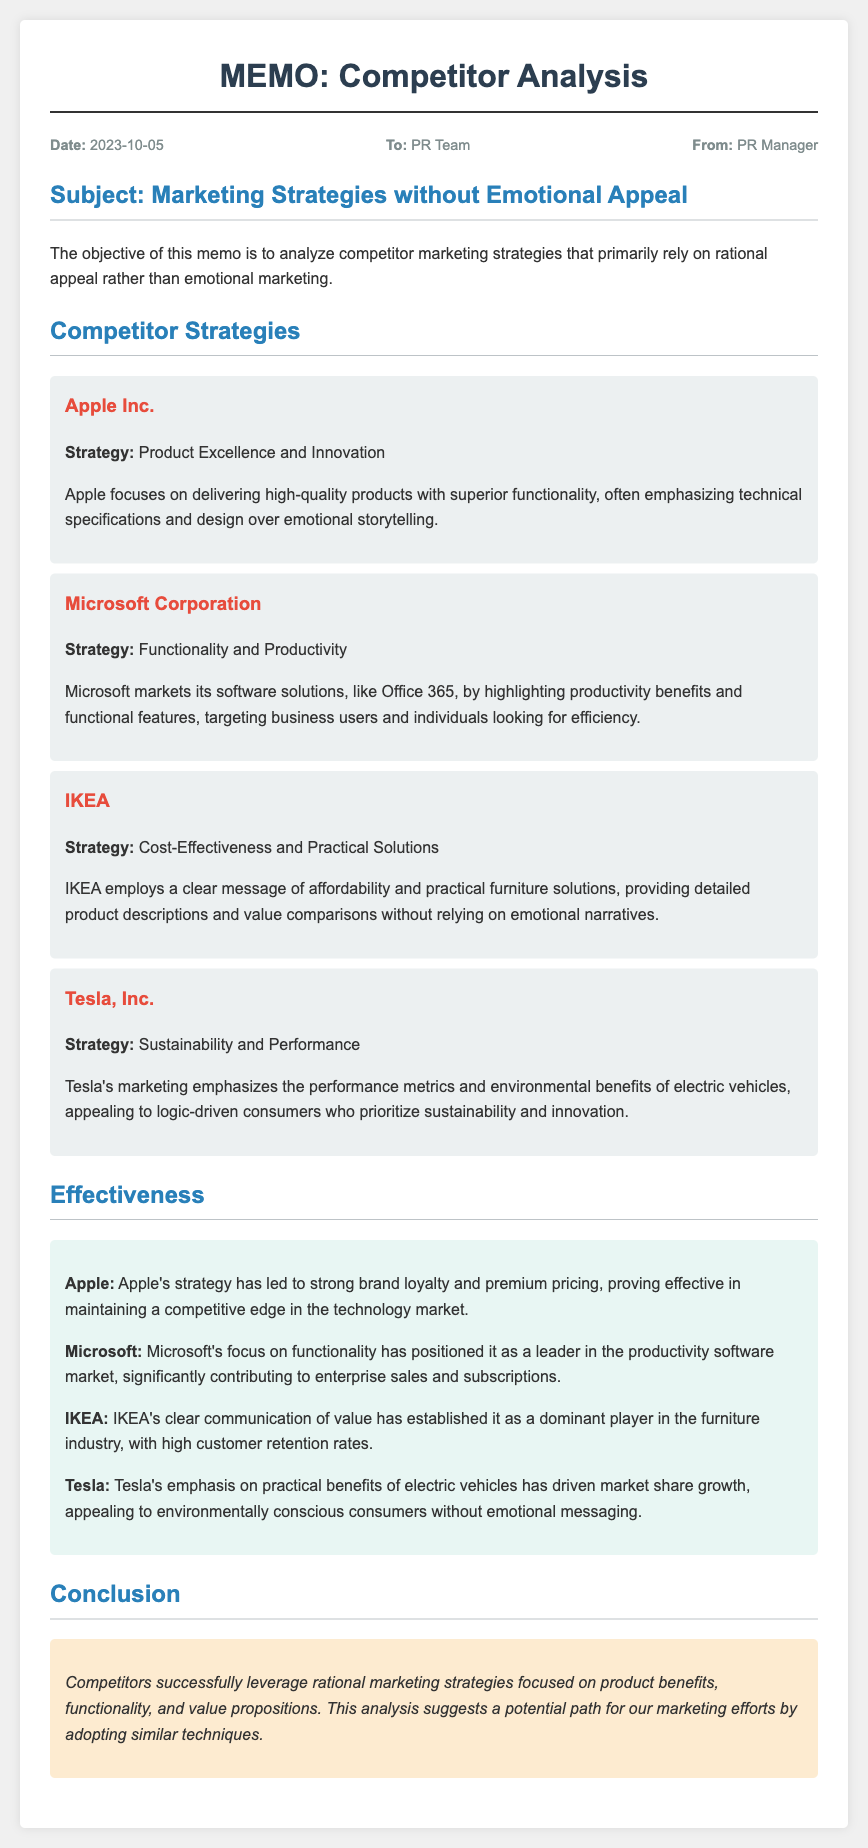What is the date of the memo? The date of the memo is explicitly stated in the meta section, which is October 5, 2023.
Answer: 2023-10-05 Who is the sender of the memo? The memo indicates the sender in the meta section, listed as the PR Manager.
Answer: PR Manager What strategy does Apple focus on? The document specifies that Apple’s strategy focuses on product excellence and innovation as a key approach.
Answer: Product Excellence and Innovation Which competitor emphasizes sustainability? The memo describes Tesla's strategy as emphasizing sustainability, highlighting its approach to marketing.
Answer: Tesla, Inc What is IKEA's marketing focus? IKEA's marketing strategy is clearly stated as being centered around cost-effectiveness and practical solutions.
Answer: Cost-Effectiveness and Practical Solutions How has Microsoft's strategy affected its market position? The effectiveness section indicates that Microsoft’s focus on functionality has significantly contributed to its enterprise sales and subscriptions.
Answer: Leader in the productivity software market What is the main conclusion drawn in the memo? The conclusion outlines that competitors effectively use rational marketing strategies focused on product benefits and value propositions.
Answer: Rational marketing strategies focused on product benefits What type of consumers does Tesla target? The memo specifies that Tesla targets logic-driven consumers who prioritize sustainability and innovation, based on its marketing emphasis.
Answer: Environmentally conscious consumers 